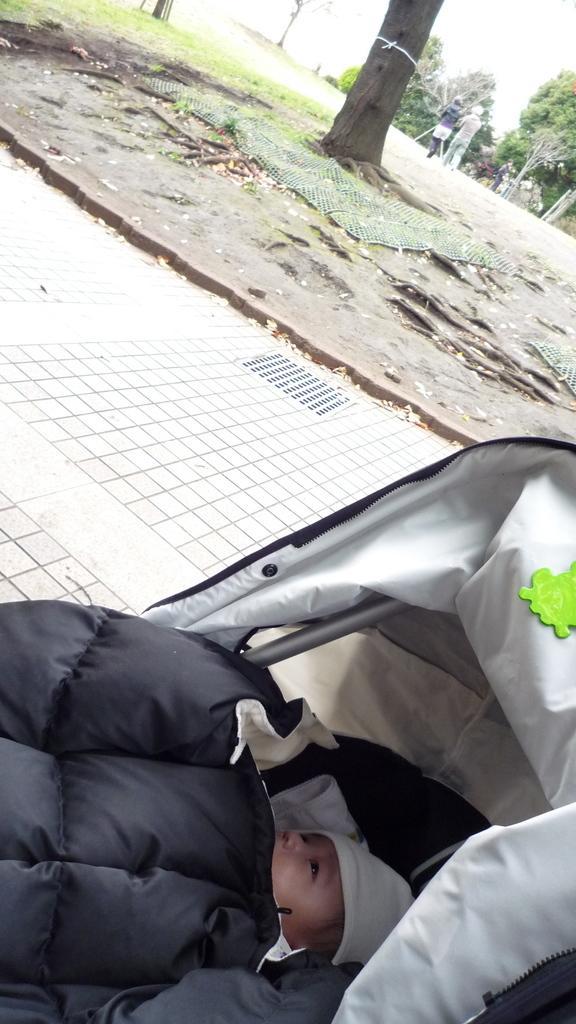Could you give a brief overview of what you see in this image? At the bottom of the image we can see a baby is lying on a baby trolley. In the background of the image we can see the road, ground, grass, mesh, trees. At the top of the image we can see some people are walking and also we can see the sky. 